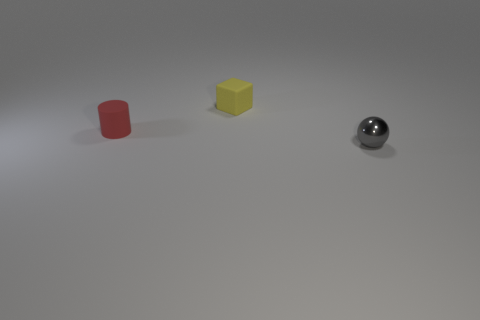Add 1 tiny blue objects. How many objects exist? 4 Subtract all cubes. How many objects are left? 2 Add 1 yellow things. How many yellow things are left? 2 Add 2 small yellow rubber cubes. How many small yellow rubber cubes exist? 3 Subtract 0 purple cylinders. How many objects are left? 3 Subtract all big cyan metal blocks. Subtract all yellow objects. How many objects are left? 2 